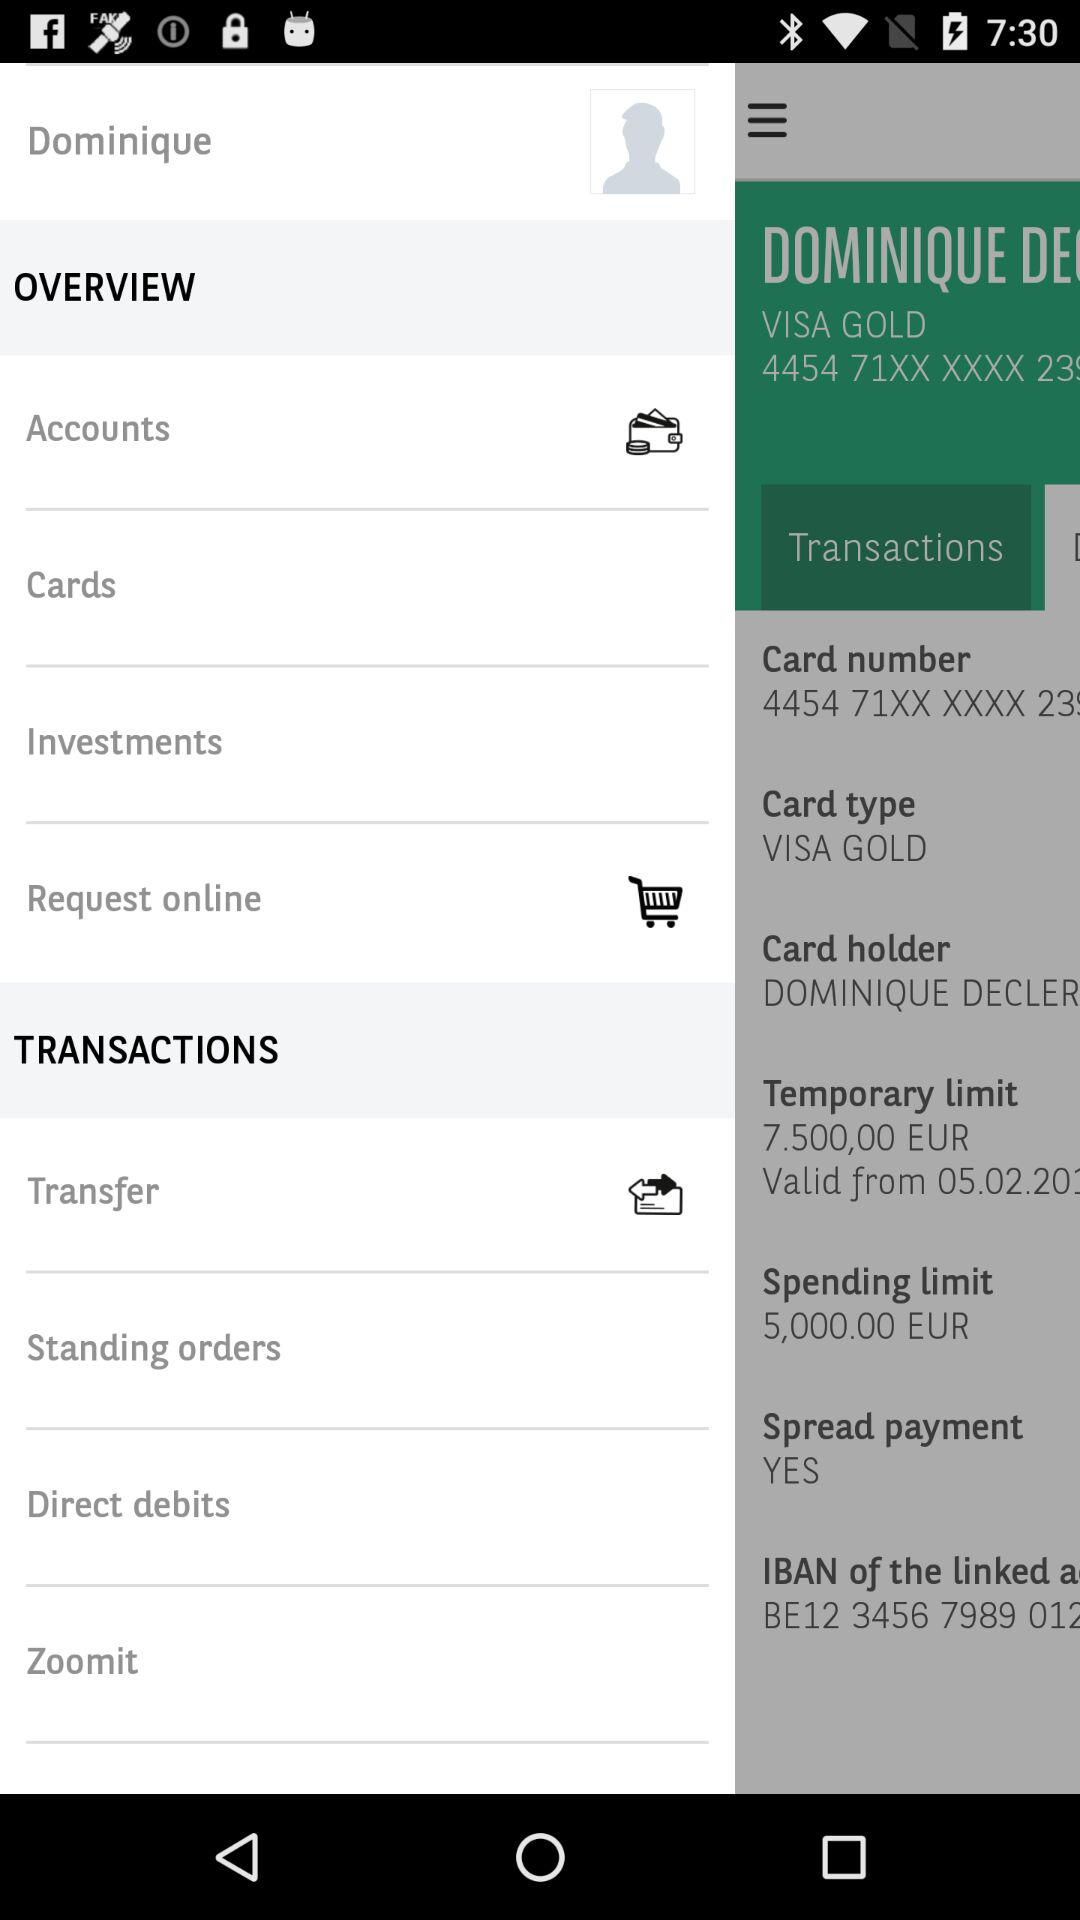What is the card holder's name? The card holder's name is Dominique. 